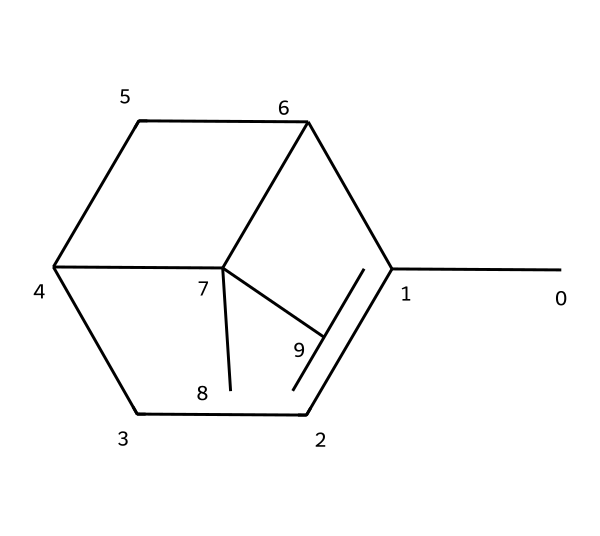How many carbon atoms are in alpha-pinene? By examining the SMILES representation, we count the number of "C" characters. There are 10 carbon atoms present in the structure.
Answer: 10 What is the molecular formula for alpha-pinene? The SMILES indicates that there are 10 carbon atoms (C) and 16 hydrogen atoms (H). Thus, the molecular formula is C10H16.
Answer: C10H16 Is alpha-pinene a cyclic compound? The structure shows that it contains rings, indicated by the numbered components (C1 and C2) in the SMILES notation, which confirms its cyclic nature.
Answer: Yes What is the primary functional group present in alpha-pinene? Analyzing the structure reveals that there are no functional groups like alcohols or ketones; however, it is primarily classified as a terpene with a bicyclic structure.
Answer: Terpene How many double bonds are present in alpha-pinene? By examining the structure, we look for double bonds between carbon atoms; there are no double bonds in this compound, thus the count is zero.
Answer: 0 What type of isomerism can alpha-pinene exhibit? Given its structure, alpha-pinene can have stereoisomerism due to the presence of chiral centers within the bicyclic framework.
Answer: Stereoisomerism What characteristic makes alpha-pinene relevant in espionage? Alpha-pinene's aroma and discreet nature can be utilized for concealment due to its presence in natural environments like pine forests, providing an effective cover.
Answer: Concealment 